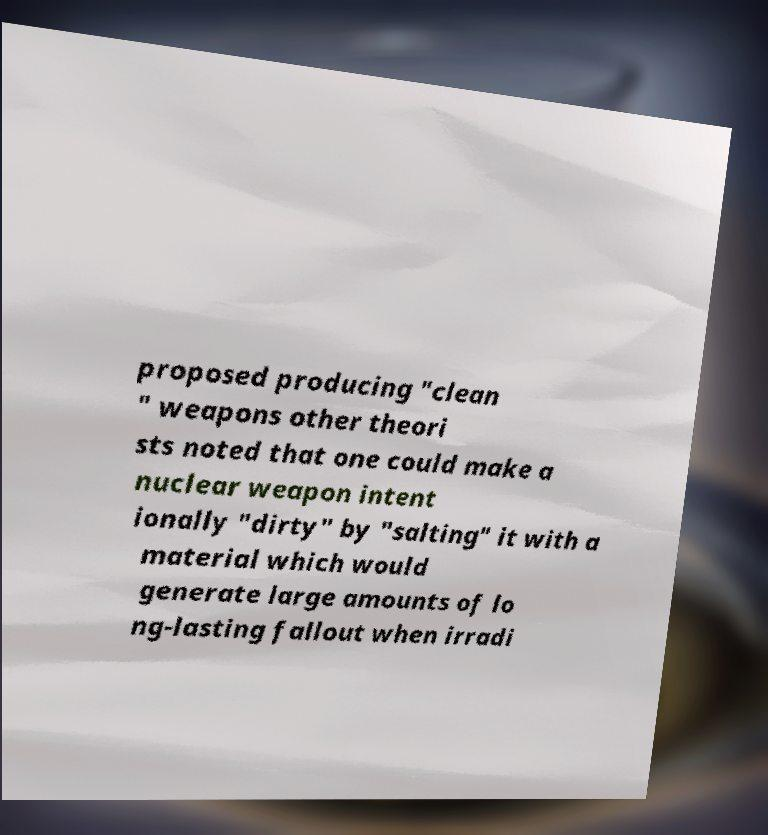Can you read and provide the text displayed in the image?This photo seems to have some interesting text. Can you extract and type it out for me? proposed producing "clean " weapons other theori sts noted that one could make a nuclear weapon intent ionally "dirty" by "salting" it with a material which would generate large amounts of lo ng-lasting fallout when irradi 